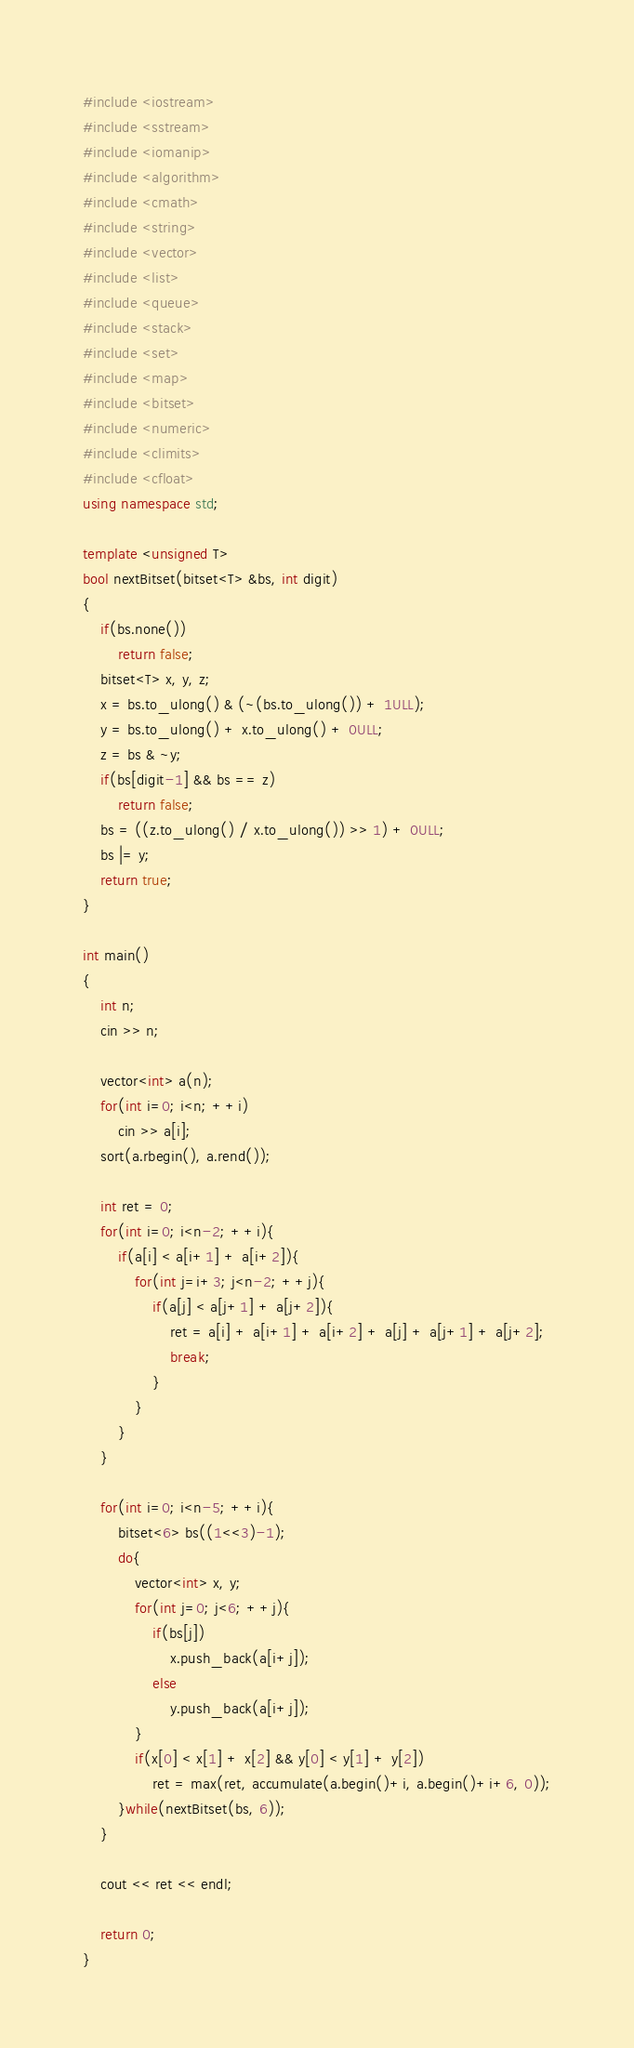Convert code to text. <code><loc_0><loc_0><loc_500><loc_500><_C++_>#include <iostream>
#include <sstream>
#include <iomanip>
#include <algorithm>
#include <cmath>
#include <string>
#include <vector>
#include <list>
#include <queue>
#include <stack>
#include <set>
#include <map>
#include <bitset>
#include <numeric>
#include <climits>
#include <cfloat>
using namespace std;

template <unsigned T>
bool nextBitset(bitset<T> &bs, int digit)
{
    if(bs.none())
        return false;
    bitset<T> x, y, z;
    x = bs.to_ulong() & (~(bs.to_ulong()) + 1ULL);
    y = bs.to_ulong() + x.to_ulong() + 0ULL;
    z = bs & ~y;
    if(bs[digit-1] && bs == z)
        return false;
    bs = ((z.to_ulong() / x.to_ulong()) >> 1) + 0ULL;
    bs |= y;
    return true;
}

int main()
{
    int n;
    cin >> n;

    vector<int> a(n);
    for(int i=0; i<n; ++i)
        cin >> a[i];
    sort(a.rbegin(), a.rend());

    int ret = 0;
    for(int i=0; i<n-2; ++i){
        if(a[i] < a[i+1] + a[i+2]){
            for(int j=i+3; j<n-2; ++j){
                if(a[j] < a[j+1] + a[j+2]){
                    ret = a[i] + a[i+1] + a[i+2] + a[j] + a[j+1] + a[j+2];
                    break;
                }
            }
        }
    }

    for(int i=0; i<n-5; ++i){
        bitset<6> bs((1<<3)-1);
        do{
            vector<int> x, y;
            for(int j=0; j<6; ++j){
                if(bs[j])
                    x.push_back(a[i+j]);
                else
                    y.push_back(a[i+j]);
            }
            if(x[0] < x[1] + x[2] && y[0] < y[1] + y[2])
                ret = max(ret, accumulate(a.begin()+i, a.begin()+i+6, 0));
        }while(nextBitset(bs, 6));
    }

    cout << ret << endl;

    return 0;
}</code> 